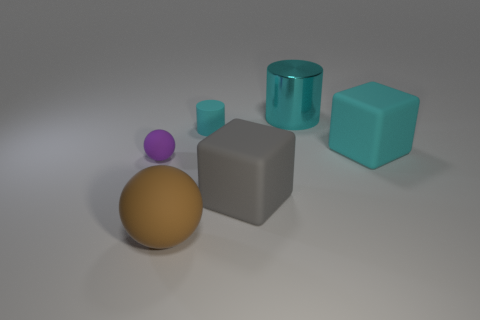Add 3 big metallic things. How many objects exist? 9 Subtract all blocks. How many objects are left? 4 Subtract all matte cubes. Subtract all gray metal cylinders. How many objects are left? 4 Add 1 matte cylinders. How many matte cylinders are left? 2 Add 3 large brown things. How many large brown things exist? 4 Subtract 0 gray spheres. How many objects are left? 6 